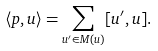Convert formula to latex. <formula><loc_0><loc_0><loc_500><loc_500>\langle p , u \rangle = \sum _ { u ^ { \prime } \in M ( u ) } [ u ^ { \prime } , u ] .</formula> 